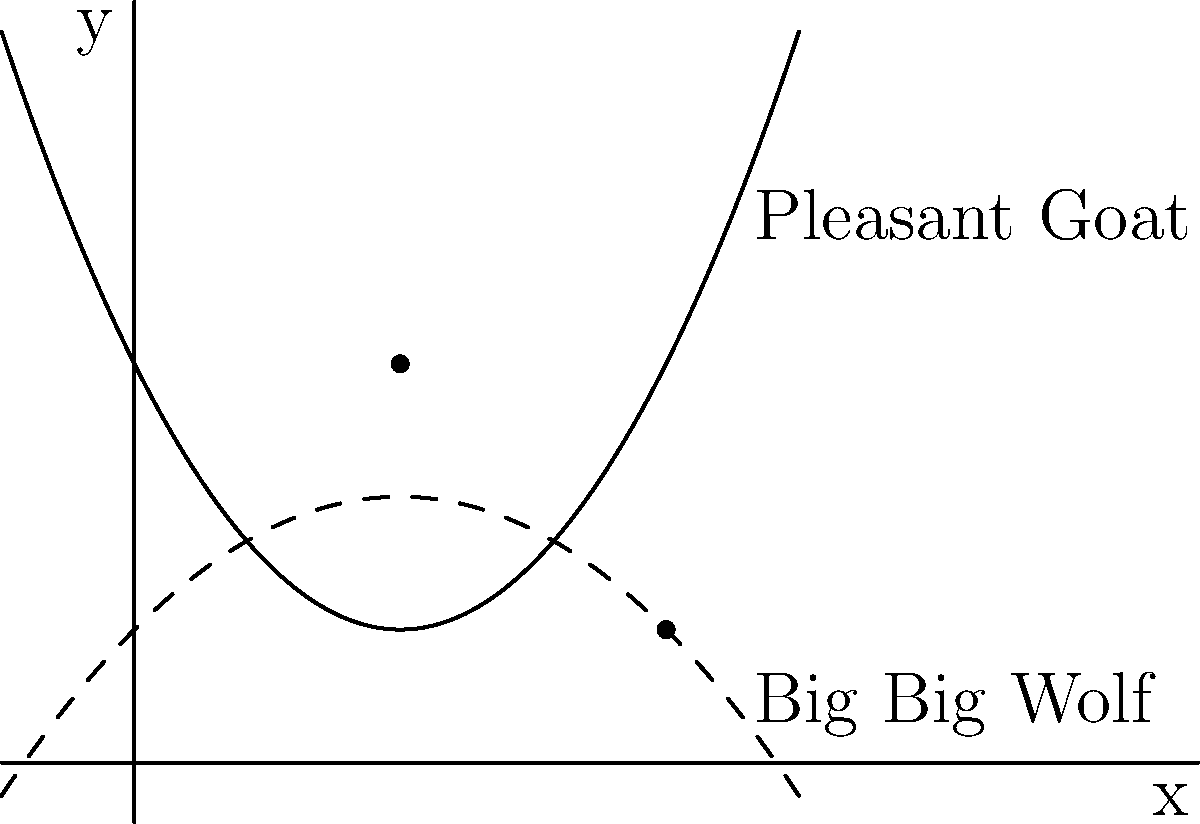Pleasant Goat and Big Big Wolf are running on a basketball court. Their paths can be represented by polynomial functions. Pleasant Goat's path is given by $f(x) = 0.5x^2 - 2x + 3$, while Big Big Wolf's path is given by $g(x) = -0.25x^2 + x + 1$, where $x$ represents the distance in meters and $y$ represents the lateral position on the court. At how many points do their paths intersect, and what are the $x$-coordinates of these intersection points? To find the intersection points, we need to solve the equation $f(x) = g(x)$:

1) Set up the equation:
   $0.5x^2 - 2x + 3 = -0.25x^2 + x + 1$

2) Rearrange terms:
   $0.5x^2 + 0.25x^2 - 2x - x + 3 - 1 = 0$
   $0.75x^2 - 3x + 2 = 0$

3) Multiply all terms by 4 to simplify coefficients:
   $3x^2 - 12x + 8 = 0$

4) This is a quadratic equation. We can solve it using the quadratic formula:
   $x = \frac{-b \pm \sqrt{b^2 - 4ac}}{2a}$

   Where $a = 3$, $b = -12$, and $c = 8$

5) Substituting these values:
   $x = \frac{12 \pm \sqrt{144 - 96}}{6} = \frac{12 \pm \sqrt{48}}{6} = \frac{12 \pm 4\sqrt{3}}{6}$

6) Simplifying:
   $x = 2 \pm \frac{2\sqrt{3}}{3}$

Therefore, there are two intersection points:
$x_1 = 2 + \frac{2\sqrt{3}}{3} \approx 3.15$ and $x_2 = 2 - \frac{2\sqrt{3}}{3} \approx 0.85$
Answer: 2 points; $x = 2 \pm \frac{2\sqrt{3}}{3}$ 